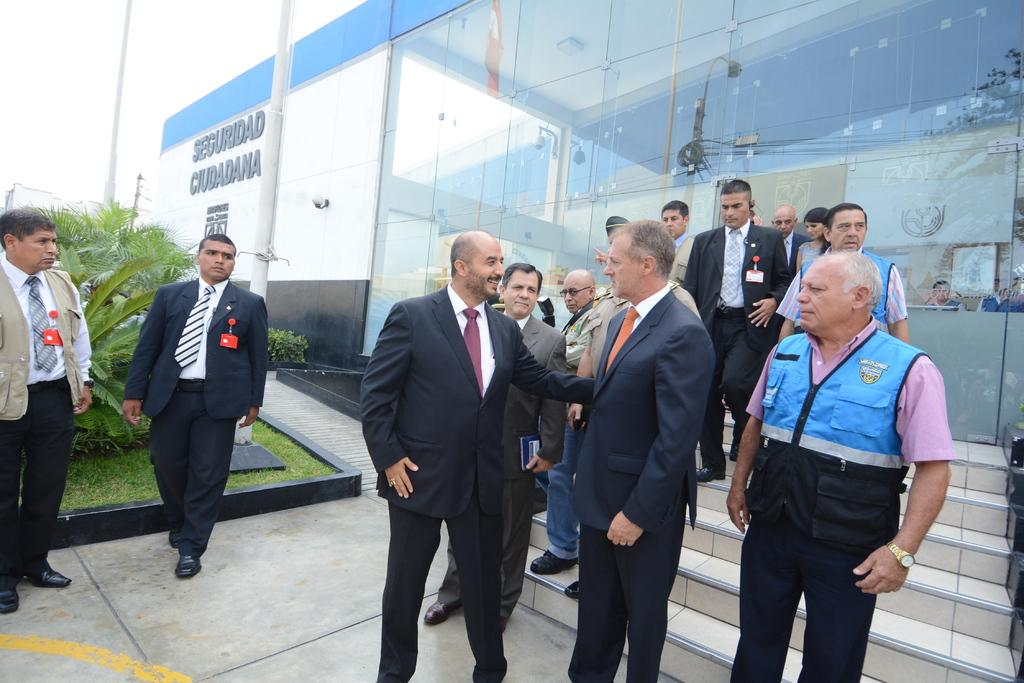What are the people in the image doing? The people in the image are standing and talking. What can be seen in the background of the image? There are stairs to a building in the background. What type of vegetation is visible to the left of the image? There are trees to the left of the image. Can you see a receipt on the ground in the image? There is no receipt visible on the ground in the image. 